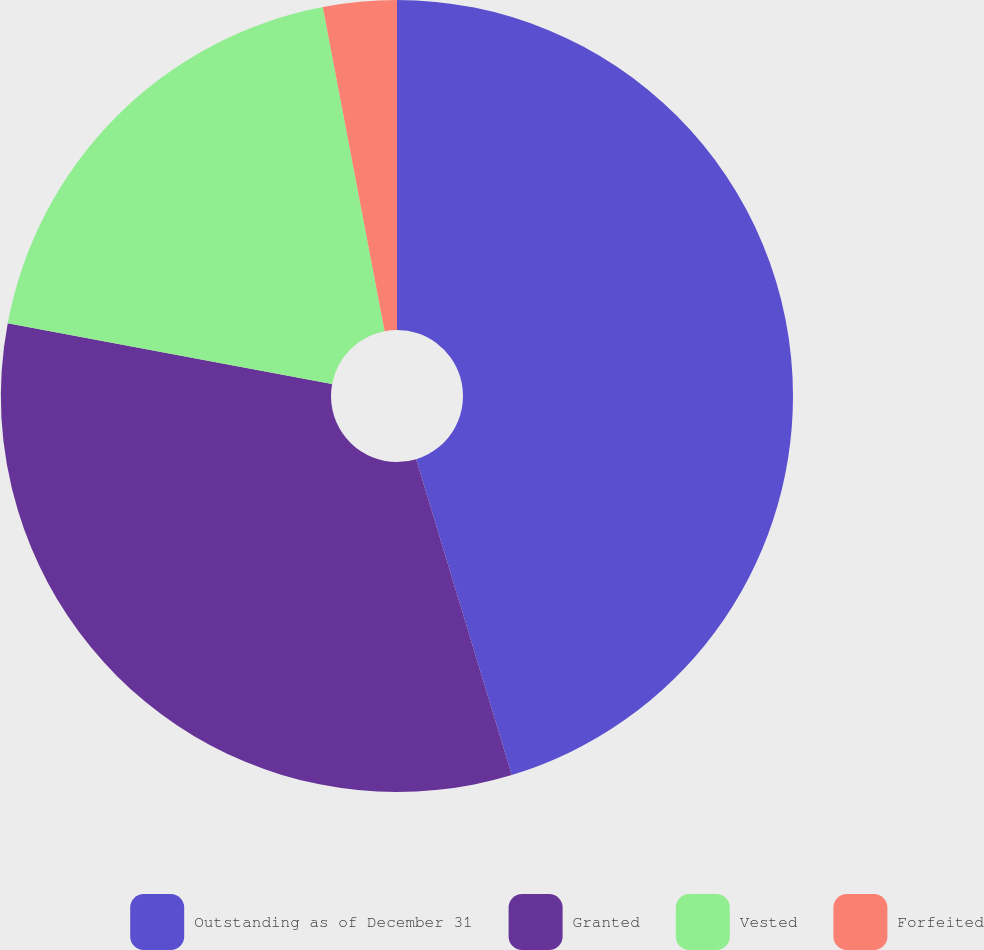Convert chart. <chart><loc_0><loc_0><loc_500><loc_500><pie_chart><fcel>Outstanding as of December 31<fcel>Granted<fcel>Vested<fcel>Forfeited<nl><fcel>45.32%<fcel>32.62%<fcel>19.06%<fcel>3.0%<nl></chart> 